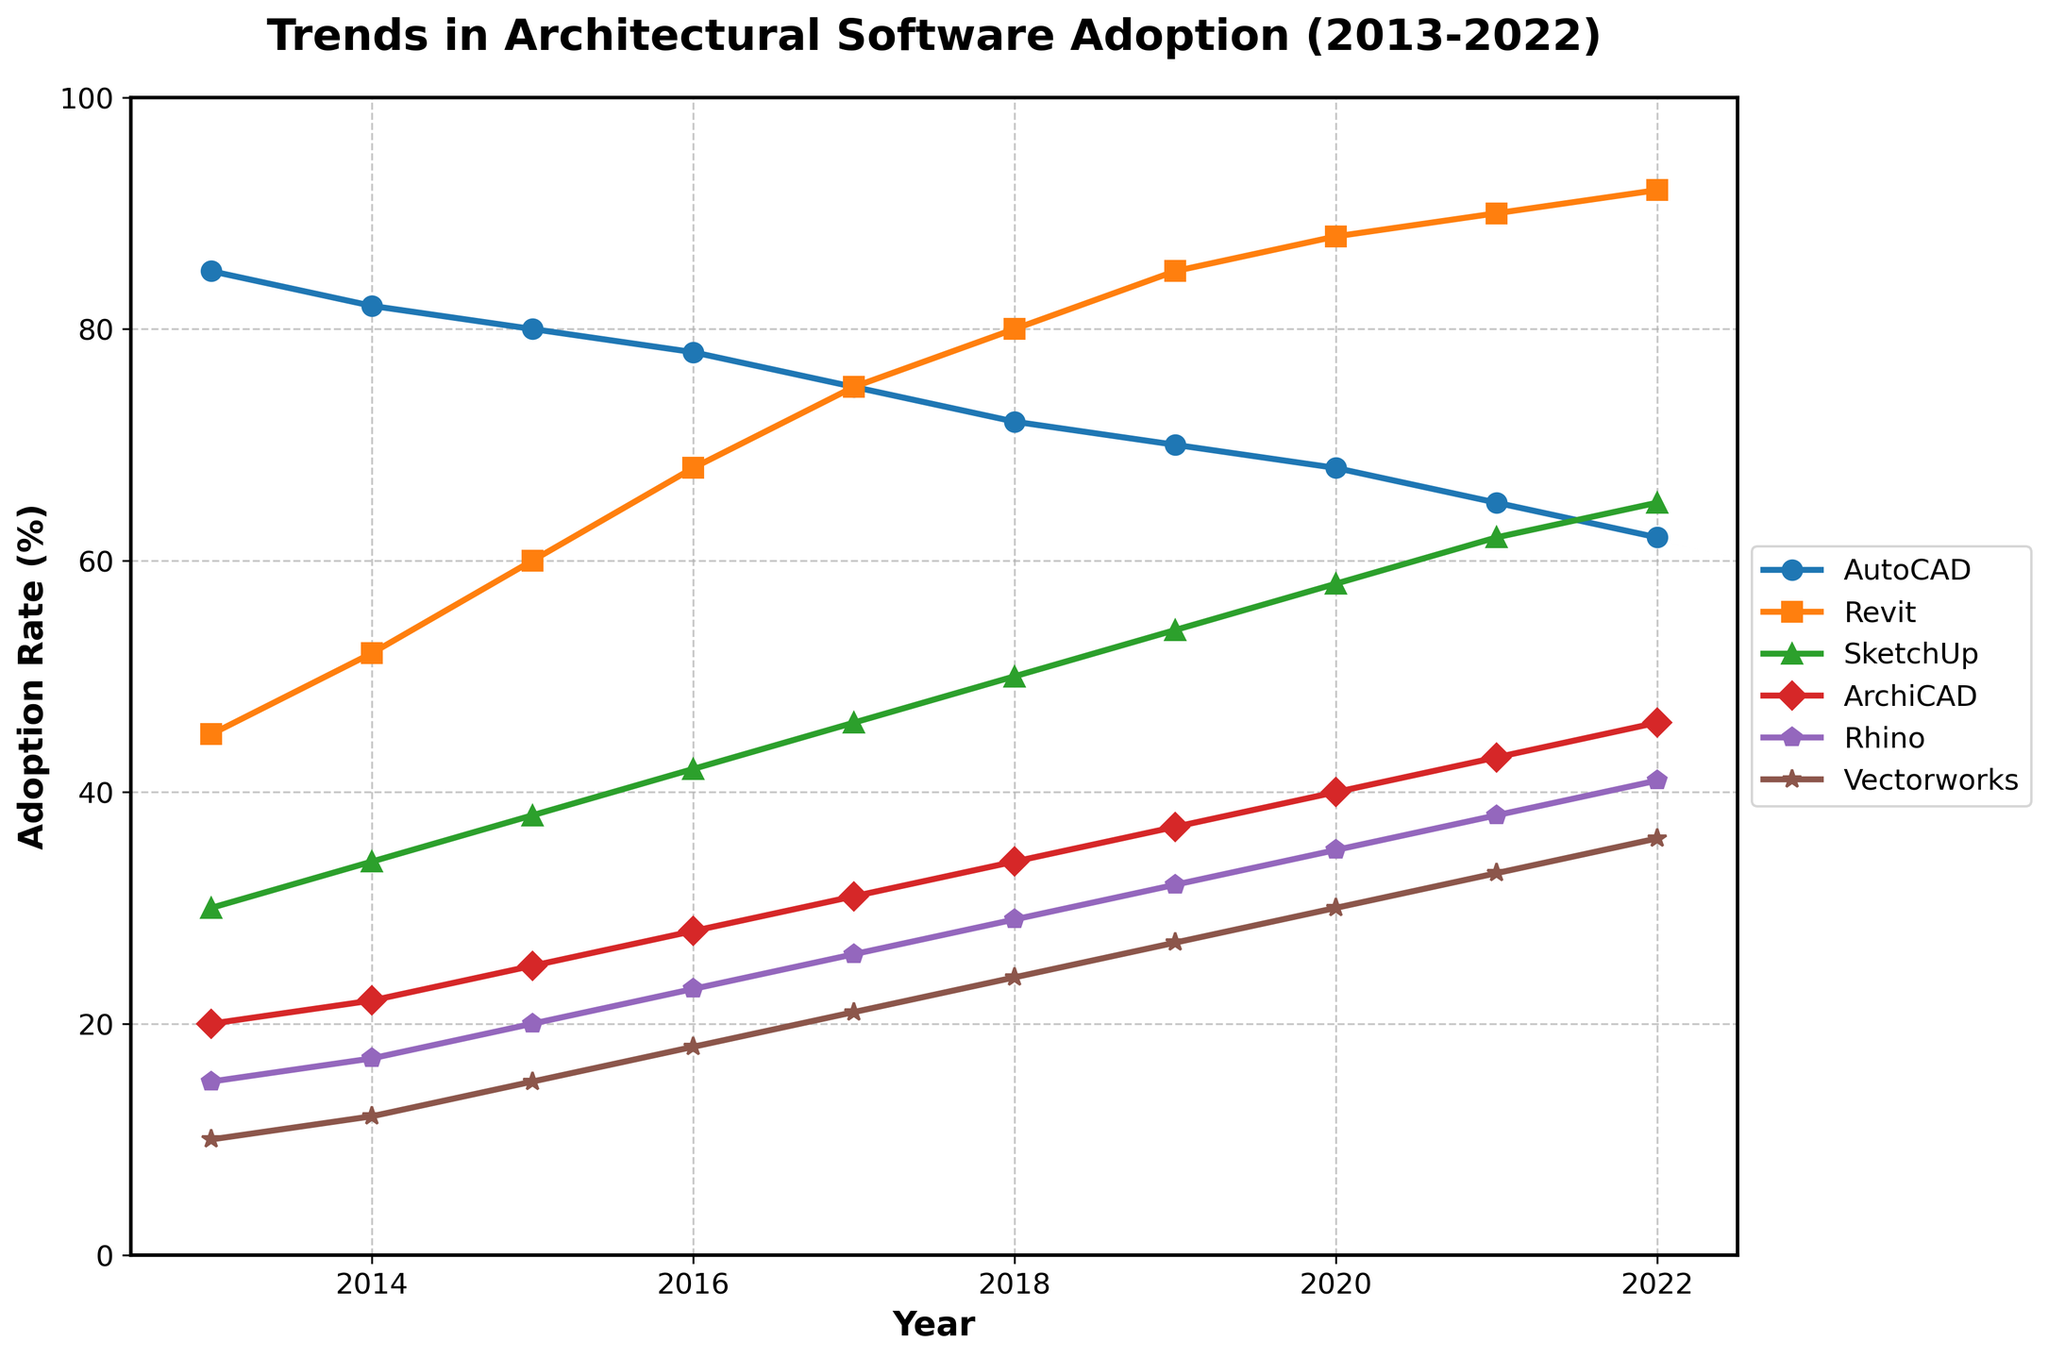Which software shows the highest adoption rate in 2022? To identify the software with the highest adoption rate in 2022, look at the data point for each software in the year 2022. Revit has the highest adoption rate.
Answer: Revit Which software had the most significant increase in adoption rate from 2013 to 2022? To determine the most significant increase, subtract the adoption rate of each software in 2013 from its adoption rate in 2022. Revit increased from 45% to 92%, showing the largest increase of 47%.
Answer: Revit How did the adoption rate of AutoCAD change from 2013 to 2022? For this, compare the adoption rates of AutoCAD in 2013 and 2022. AutoCAD's adoption rate decreased from 85% to 62%.
Answer: Decreased Between which consecutive years did SketchUp see the largest increase in adoption rate? Check the year-on-year increases for SketchUp from the data provided. The largest increase is from 2017 to 2018, where it jumped from 46% to 50%.
Answer: 2017 to 2018 Which software had the lowest adoption rate in 2013 and how did it change by 2022? Check the adoption rates for each software in 2013 and identify the lowest one. Vectorworks had the lowest at 10%, and it increased to 36% by 2022.
Answer: Vectorworks, increased Compare the adoption rates of Rhino and ArchiCAD in 2017. Which was higher and by how much? Look at the data points for Rhino and ArchiCAD in 2017. Rhino was at 26% and ArchiCAD at 31%. ArchiCAD was higher by 5%.
Answer: ArchiCAD, 5% What's the average adoption rate of Revit over the decade? Sum the adoption rates of Revit for each year from 2013 to 2022 and divide by the number of years. (45+52+60+68+75+80+85+88+90+92) / 10 = 73.5%.
Answer: 73.5% What is the overall trend in the adoption of AutoCAD from 2013 to 2022? Analyze the data for AutoCAD across the years. There is a clear downward trend, with adoption rates decreasing almost every year.
Answer: Downward Which software's adoption rate stayed consistently below 50% throughout the decade? Review the maximum adoption rates of each software over the years. Only ArchiCAD and Vectorworks never exceed 50%.
Answer: ArchiCAD, Vectorworks Consider the adoption rates of SketchUp and Rhino in 2020. Which had a higher rate, and what’s the difference? SketchUp's adoption rate in 2020 was 58%, and Rhino's was 35%. SketchUp was higher by 23%.
Answer: SketchUp, 23% 